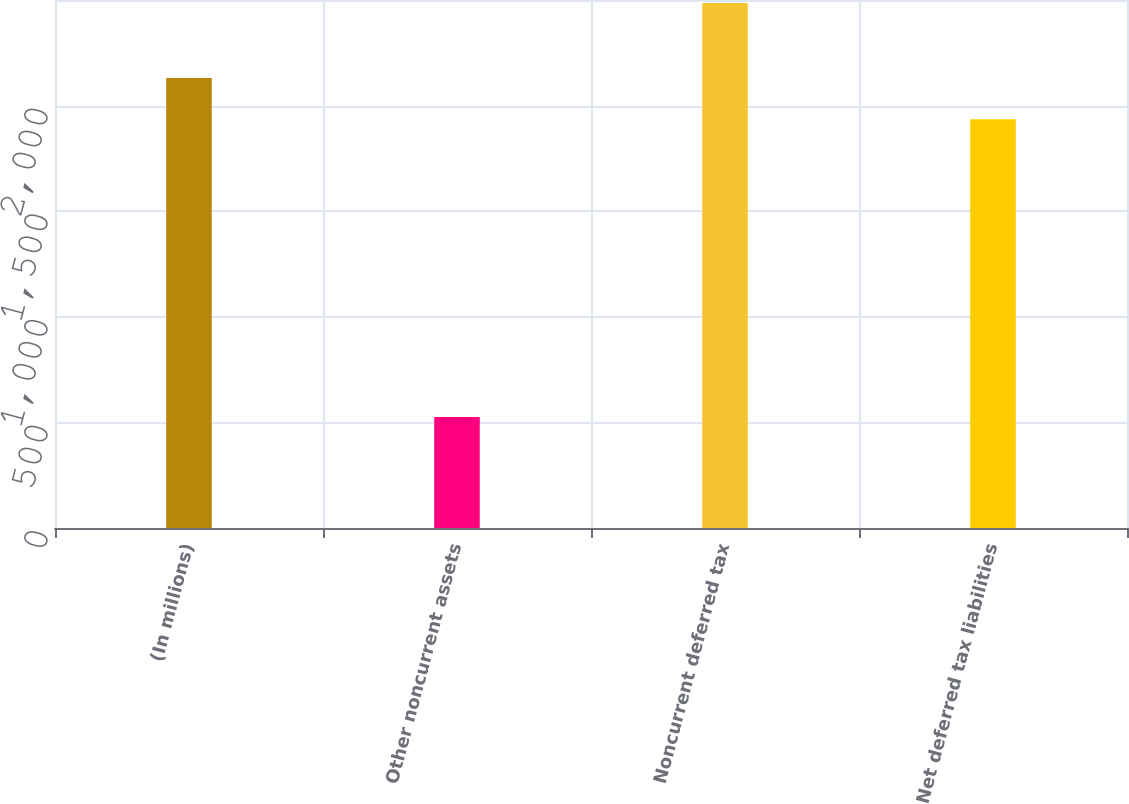<chart> <loc_0><loc_0><loc_500><loc_500><bar_chart><fcel>(In millions)<fcel>Other noncurrent assets<fcel>Noncurrent deferred tax<fcel>Net deferred tax liabilities<nl><fcel>2131.1<fcel>525<fcel>2486<fcel>1935<nl></chart> 